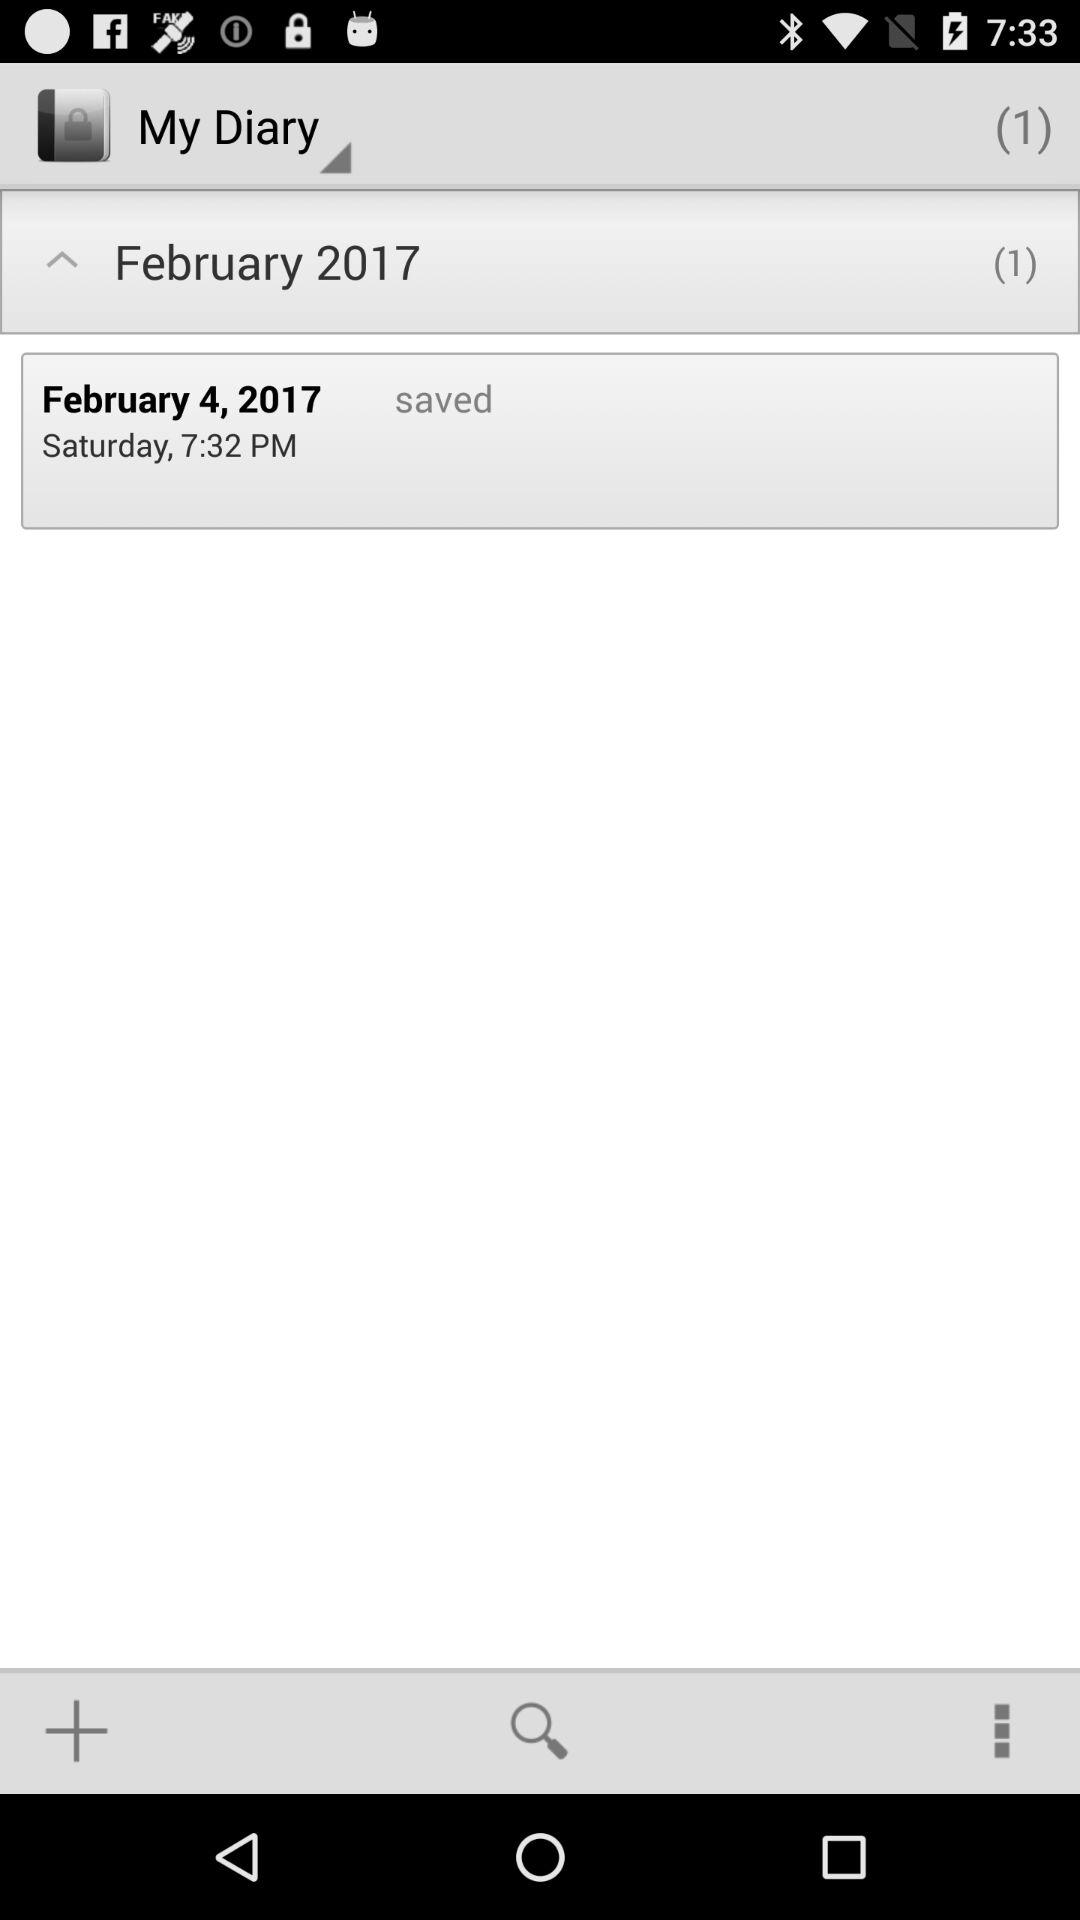What is the time and day on which the note is saved? The time and day on which the note is saved are Saturday, 7:32 PM. 